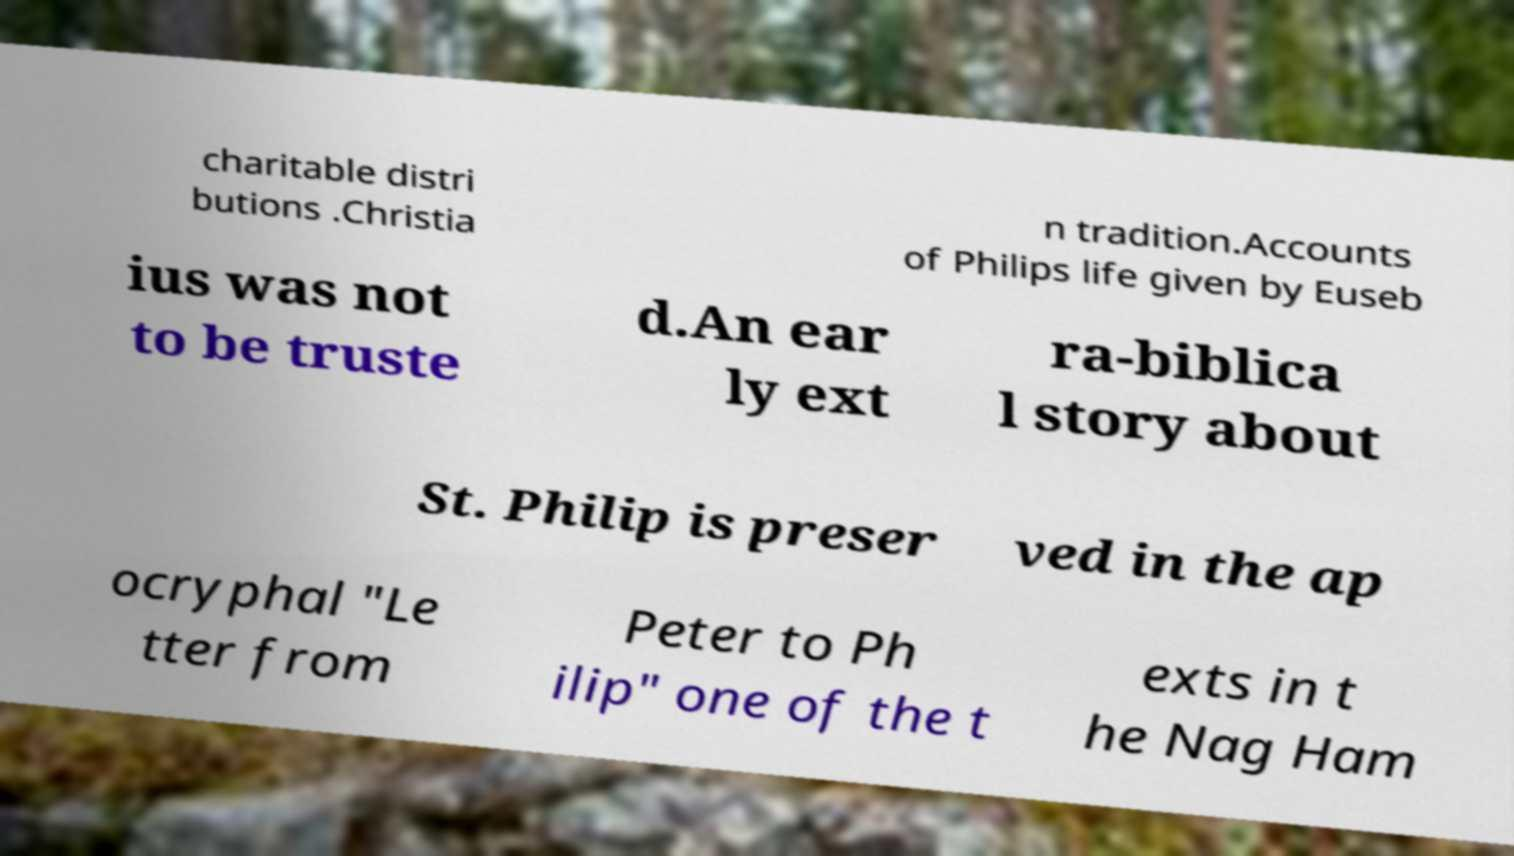Could you extract and type out the text from this image? charitable distri butions .Christia n tradition.Accounts of Philips life given by Euseb ius was not to be truste d.An ear ly ext ra-biblica l story about St. Philip is preser ved in the ap ocryphal "Le tter from Peter to Ph ilip" one of the t exts in t he Nag Ham 